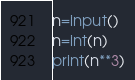Convert code to text. <code><loc_0><loc_0><loc_500><loc_500><_Python_>n=input()
n=int(n)
print(n**3)</code> 